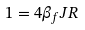<formula> <loc_0><loc_0><loc_500><loc_500>1 = 4 \beta _ { f } J R</formula> 